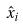<formula> <loc_0><loc_0><loc_500><loc_500>\hat { x } _ { i }</formula> 